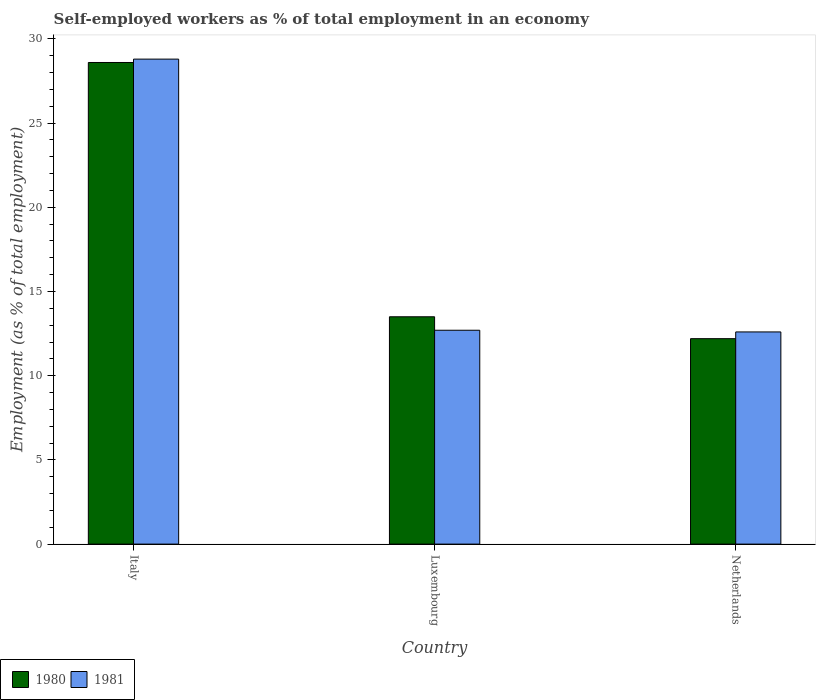How many groups of bars are there?
Give a very brief answer. 3. Are the number of bars per tick equal to the number of legend labels?
Ensure brevity in your answer.  Yes. How many bars are there on the 3rd tick from the right?
Your answer should be compact. 2. What is the label of the 3rd group of bars from the left?
Give a very brief answer. Netherlands. In how many cases, is the number of bars for a given country not equal to the number of legend labels?
Provide a short and direct response. 0. What is the percentage of self-employed workers in 1981 in Netherlands?
Offer a terse response. 12.6. Across all countries, what is the maximum percentage of self-employed workers in 1980?
Make the answer very short. 28.6. Across all countries, what is the minimum percentage of self-employed workers in 1980?
Your answer should be very brief. 12.2. What is the total percentage of self-employed workers in 1980 in the graph?
Your answer should be very brief. 54.3. What is the difference between the percentage of self-employed workers in 1980 in Italy and that in Luxembourg?
Make the answer very short. 15.1. What is the difference between the percentage of self-employed workers in 1981 in Netherlands and the percentage of self-employed workers in 1980 in Italy?
Your response must be concise. -16. What is the average percentage of self-employed workers in 1981 per country?
Give a very brief answer. 18.03. What is the difference between the percentage of self-employed workers of/in 1981 and percentage of self-employed workers of/in 1980 in Italy?
Offer a terse response. 0.2. In how many countries, is the percentage of self-employed workers in 1980 greater than 11 %?
Your answer should be compact. 3. What is the ratio of the percentage of self-employed workers in 1980 in Italy to that in Luxembourg?
Offer a very short reply. 2.12. What is the difference between the highest and the second highest percentage of self-employed workers in 1980?
Your answer should be very brief. 15.1. What is the difference between the highest and the lowest percentage of self-employed workers in 1980?
Offer a very short reply. 16.4. What does the 1st bar from the right in Luxembourg represents?
Your response must be concise. 1981. Does the graph contain grids?
Your answer should be compact. No. How are the legend labels stacked?
Your response must be concise. Horizontal. What is the title of the graph?
Ensure brevity in your answer.  Self-employed workers as % of total employment in an economy. Does "2009" appear as one of the legend labels in the graph?
Keep it short and to the point. No. What is the label or title of the Y-axis?
Keep it short and to the point. Employment (as % of total employment). What is the Employment (as % of total employment) in 1980 in Italy?
Your answer should be compact. 28.6. What is the Employment (as % of total employment) of 1981 in Italy?
Offer a very short reply. 28.8. What is the Employment (as % of total employment) of 1981 in Luxembourg?
Provide a short and direct response. 12.7. What is the Employment (as % of total employment) in 1980 in Netherlands?
Give a very brief answer. 12.2. What is the Employment (as % of total employment) in 1981 in Netherlands?
Your response must be concise. 12.6. Across all countries, what is the maximum Employment (as % of total employment) of 1980?
Offer a terse response. 28.6. Across all countries, what is the maximum Employment (as % of total employment) of 1981?
Keep it short and to the point. 28.8. Across all countries, what is the minimum Employment (as % of total employment) of 1980?
Offer a terse response. 12.2. Across all countries, what is the minimum Employment (as % of total employment) in 1981?
Give a very brief answer. 12.6. What is the total Employment (as % of total employment) in 1980 in the graph?
Your answer should be compact. 54.3. What is the total Employment (as % of total employment) of 1981 in the graph?
Give a very brief answer. 54.1. What is the difference between the Employment (as % of total employment) in 1980 in Italy and that in Luxembourg?
Give a very brief answer. 15.1. What is the difference between the Employment (as % of total employment) of 1981 in Italy and that in Luxembourg?
Make the answer very short. 16.1. What is the difference between the Employment (as % of total employment) in 1981 in Italy and that in Netherlands?
Make the answer very short. 16.2. What is the difference between the Employment (as % of total employment) in 1980 in Italy and the Employment (as % of total employment) in 1981 in Luxembourg?
Offer a terse response. 15.9. What is the average Employment (as % of total employment) of 1981 per country?
Give a very brief answer. 18.03. What is the difference between the Employment (as % of total employment) of 1980 and Employment (as % of total employment) of 1981 in Netherlands?
Your answer should be very brief. -0.4. What is the ratio of the Employment (as % of total employment) in 1980 in Italy to that in Luxembourg?
Provide a succinct answer. 2.12. What is the ratio of the Employment (as % of total employment) of 1981 in Italy to that in Luxembourg?
Your answer should be very brief. 2.27. What is the ratio of the Employment (as % of total employment) in 1980 in Italy to that in Netherlands?
Your answer should be very brief. 2.34. What is the ratio of the Employment (as % of total employment) of 1981 in Italy to that in Netherlands?
Make the answer very short. 2.29. What is the ratio of the Employment (as % of total employment) in 1980 in Luxembourg to that in Netherlands?
Offer a very short reply. 1.11. What is the ratio of the Employment (as % of total employment) of 1981 in Luxembourg to that in Netherlands?
Give a very brief answer. 1.01. What is the difference between the highest and the second highest Employment (as % of total employment) in 1980?
Your answer should be compact. 15.1. What is the difference between the highest and the second highest Employment (as % of total employment) in 1981?
Ensure brevity in your answer.  16.1. 